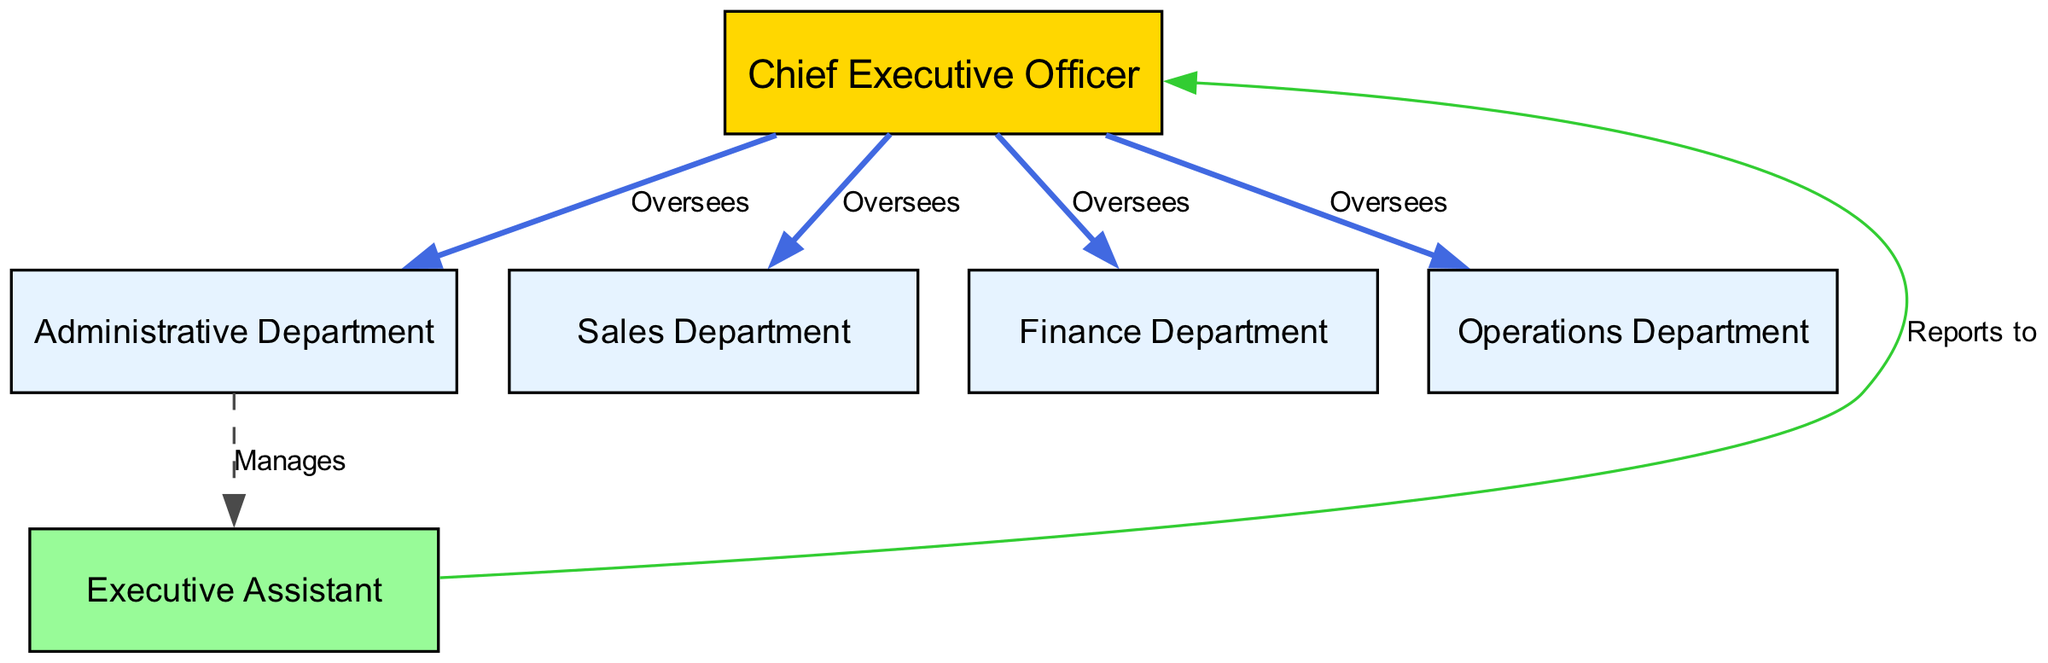What is the title of the topmost node in the diagram? The topmost node in the diagram is the Chief Executive Officer, which is represented as the highest authority in the organizational structure.
Answer: Chief Executive Officer How many departments report directly to the CEO? By examining the connections stemming from the CEO node, we can see that there are four departments (Administrative, Sales, Finance, and Operations) that report directly to the CEO.
Answer: Four Which department manages the Executive Assistant? The diagram indicates that the Administrative Department manages the Executive Assistant, as represented by the edge connecting ADMIN to EXEC_ASSISTANT with the label "Manages."
Answer: Administrative Department Who does the Executive Assistant report to? The connection from the Executive Assistant node to the CEO node indicates that the Executive Assistant reports directly to the Chief Executive Officer.
Answer: Chief Executive Officer What is the relationship between the CEO and the Sales Department? The relationship is shown by an "Oversees" edge directly connecting the CEO to the Sales Department, indicating a supervisory role.
Answer: Oversees Which department is represented with a dashed line in its connection? The connection from the Administrative Department to the Executive Assistant is represented with a dashed line, signifying a different type of relationship compared to the solid lines.
Answer: Administrative Department How many total nodes are present in the diagram? Counting the nodes (CEO, Administrative Department, Sales Department, Finance Department, Operations Department, and Executive Assistant), we find there are six nodes total in the diagram.
Answer: Six Which department has the least number of direct reporting lines? The Executive Assistant has only one direct reporting line to the CEO, whereas all other departments have direct reporting lines from the CEO. This indicates that it has the least connections.
Answer: Executive Assistant What color is assigned to the node representing the Chief Executive Officer? The Chief Executive Officer node is colored in gold (#FFD700), which distinguishes it from other nodes in the diagram.
Answer: Gold 